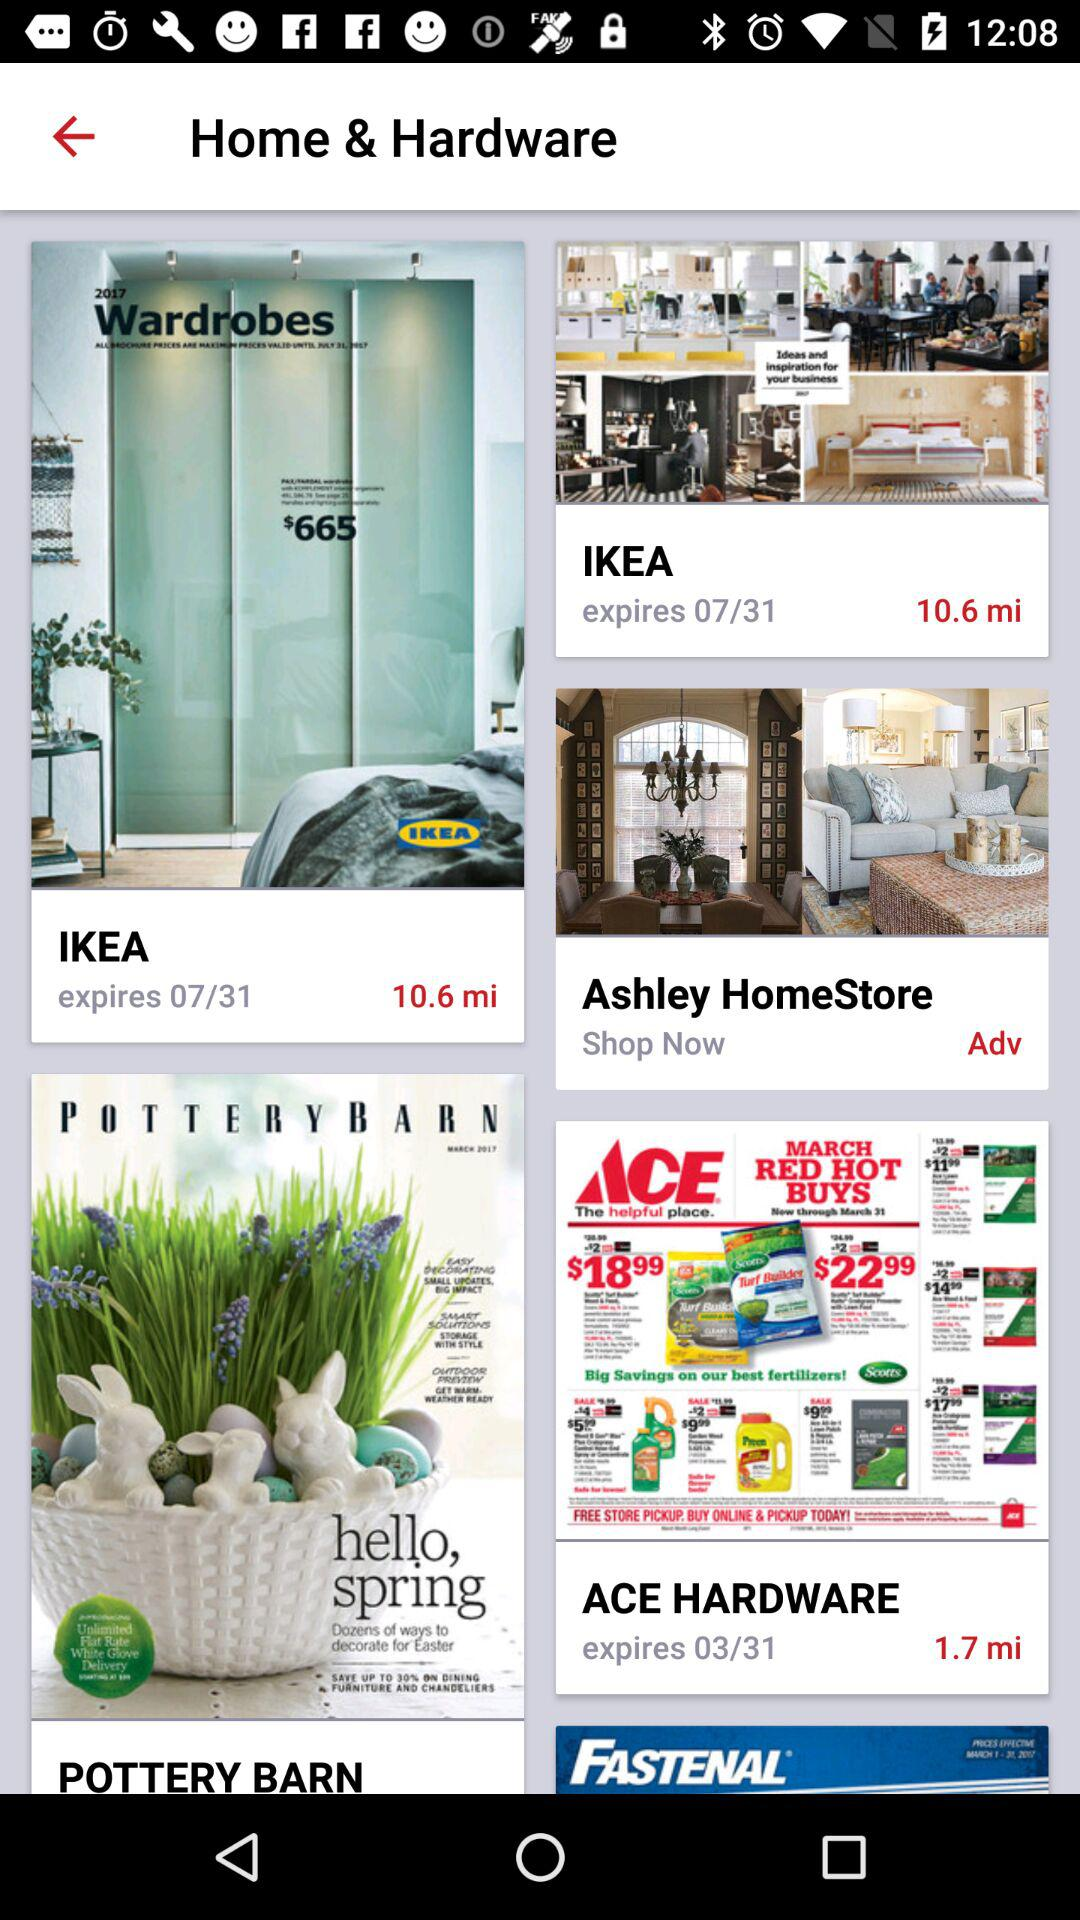What is the expiration date of IKEA? The expiration date of IKEA is 07/31. 